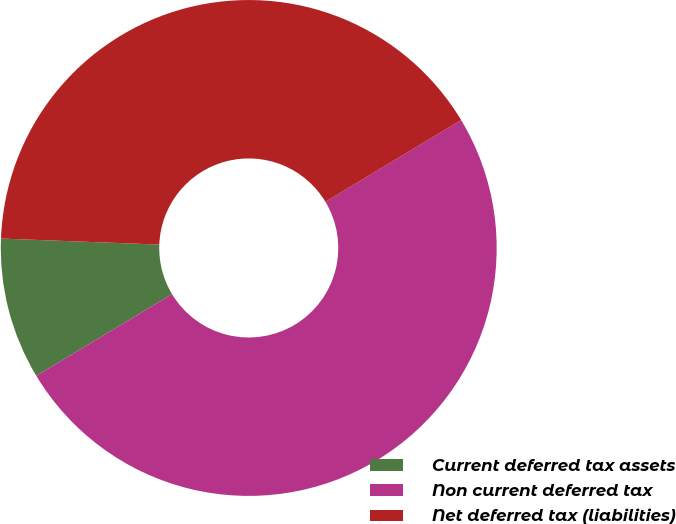Convert chart to OTSL. <chart><loc_0><loc_0><loc_500><loc_500><pie_chart><fcel>Current deferred tax assets<fcel>Non current deferred tax<fcel>Net deferred tax (liabilities)<nl><fcel>9.23%<fcel>50.0%<fcel>40.77%<nl></chart> 